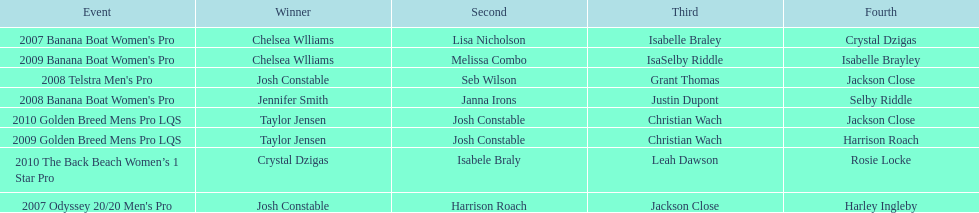How many times was josh constable second? 2. 